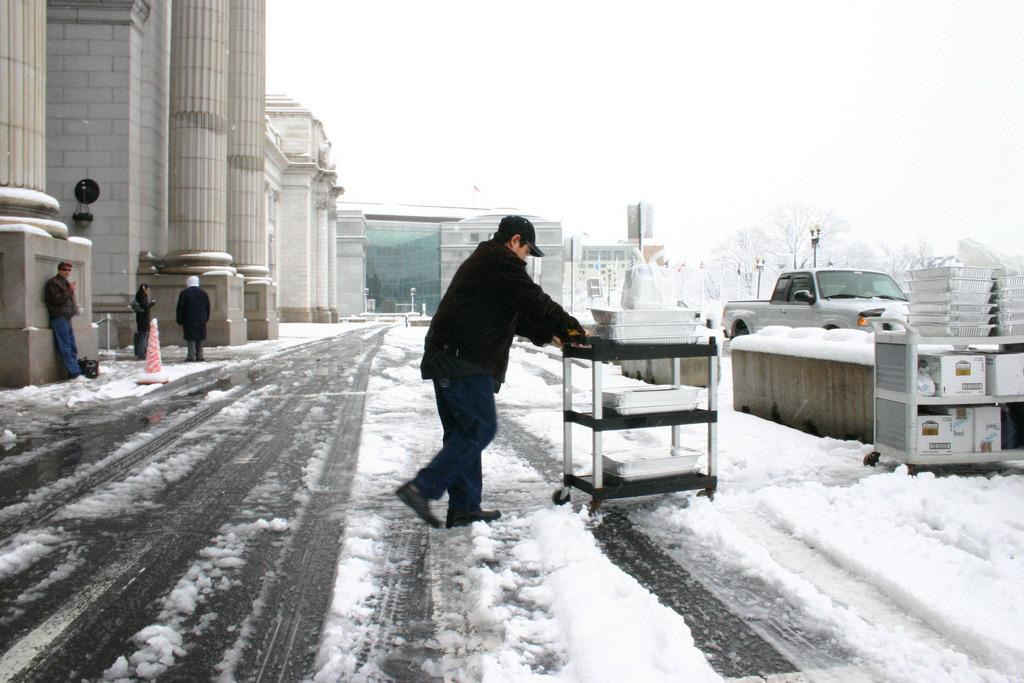What is the main subject of the image? There is a person in the image. What is the person doing in the image? The person is moving a trolley in the image. What type of surface is the trolley on? The trolley is on a snow floor. What can be seen on the left side of the image? There are buildings on the left side of the image. What is happening on the right side of the image? There is a truck moving on the right side of the image. What type of book is the monkey reading in the image? There is no monkey or book present in the image. 